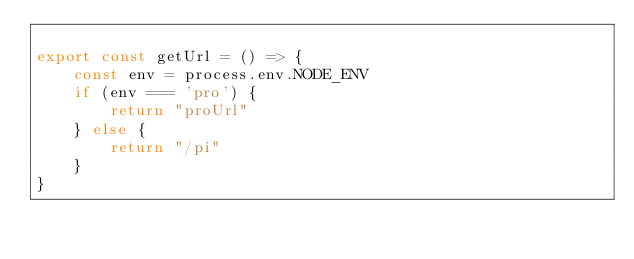Convert code to text. <code><loc_0><loc_0><loc_500><loc_500><_TypeScript_>
export const getUrl = () => {
    const env = process.env.NODE_ENV
    if (env === 'pro') {
        return "proUrl"
    } else {
        return "/pi"
    }
}</code> 